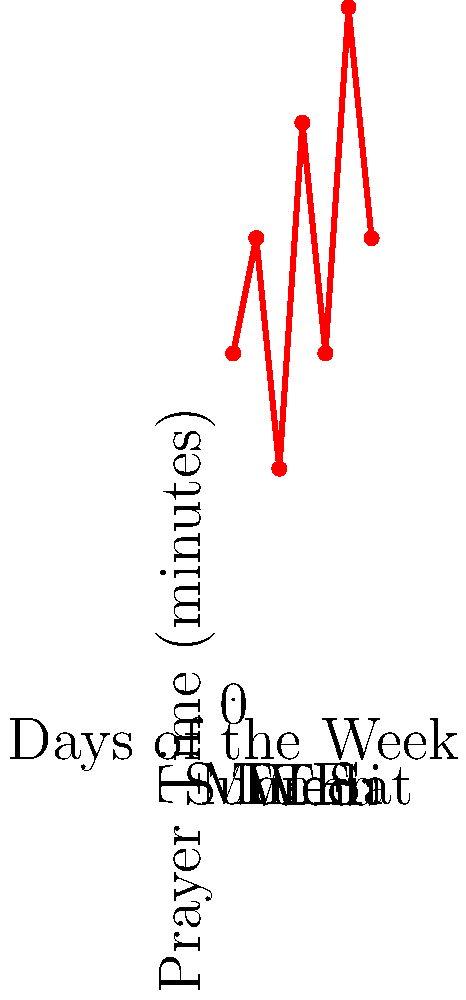As a family committed to spiritual growth, you've decided to track your family prayer time using a weekly calendar graph. The graph shows the amount of time spent in family prayer each day. On which day did your family spend the most time in prayer, and how might this information help you in fostering a consistent prayer life? To answer this question, let's analyze the graph step-by-step:

1. The x-axis represents the days of the week, from Sunday to Saturday.
2. The y-axis shows the prayer time in minutes.
3. Each data point on the graph represents the amount of time spent in family prayer for a specific day.

Looking at the graph:
1. Sunday (Sun): 15 minutes
2. Monday (Mon): 20 minutes
3. Tuesday (Tue): 10 minutes
4. Wednesday (Wed): 25 minutes
5. Thursday (Thu): 15 minutes
6. Friday (Fri): 30 minutes
7. Saturday (Sat): 20 minutes

The highest point on the graph corresponds to Friday, with 30 minutes of prayer time.

This information can help foster a consistent prayer life in several ways:
1. It provides a visual representation of your family's prayer habits throughout the week.
2. It helps identify patterns, such as which days tend to have more or less prayer time.
3. It can spark discussions about why certain days have more prayer time and how to maintain or improve consistency.
4. It allows for setting realistic goals based on your family's schedule and capabilities.
5. It can be used to celebrate progress and encourage continued commitment to family prayer time.

By regularly tracking and reviewing this information, you can make informed decisions about how to adjust your family's schedule or approach to ensure consistent and meaningful prayer time throughout the week.
Answer: Friday, 30 minutes 